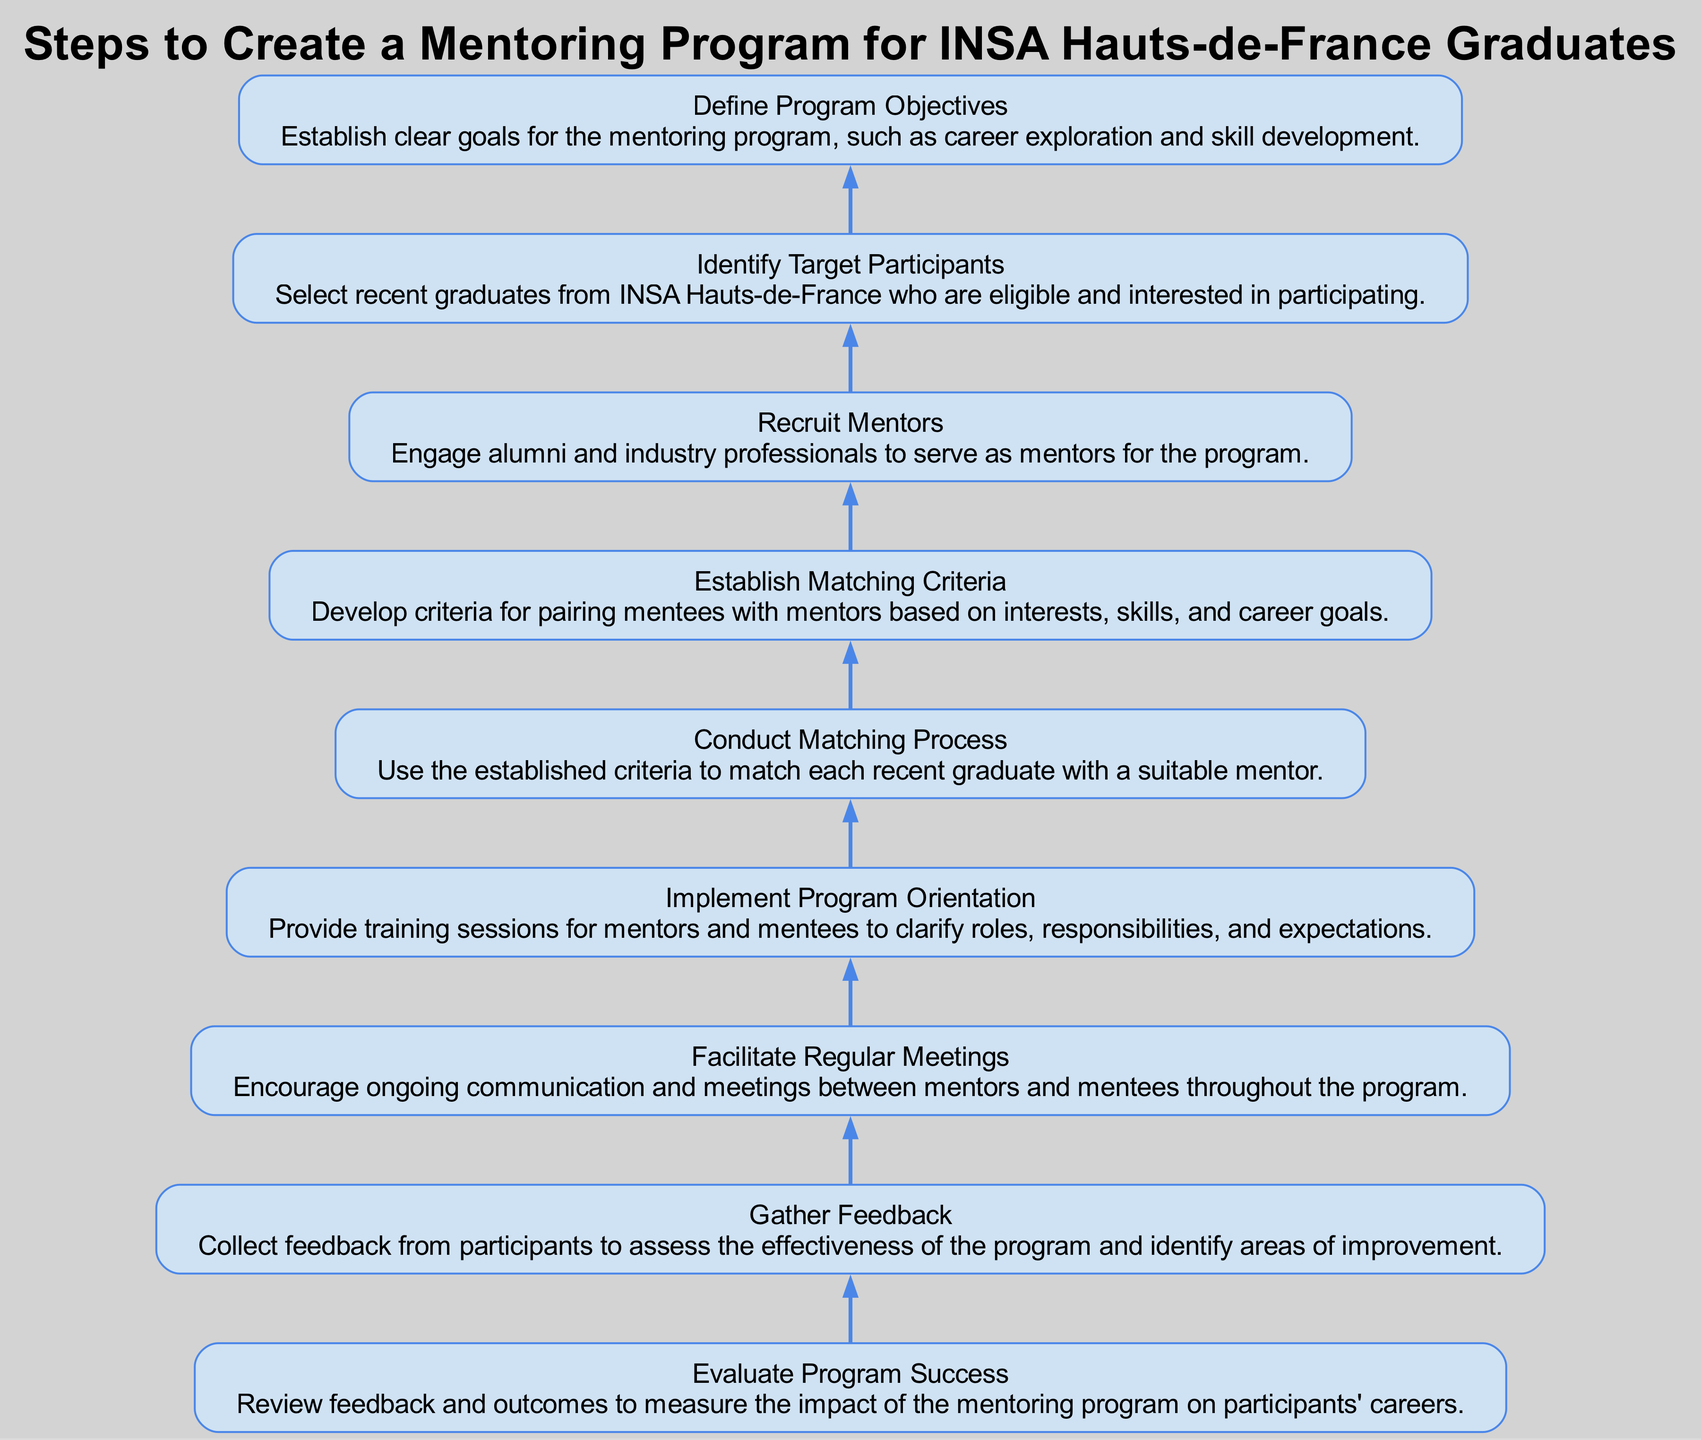What is the first step in the mentoring program? The first step is to "Define Program Objectives". This is the starting point in the flow chart, as it is at the bottom before any other process begins.
Answer: Define Program Objectives How many nodes are in the diagram? The diagram contains a total of nine nodes, which represent different steps in creating the mentoring program. Each step is a distinct node in the flow.
Answer: Nine What is the last step of the mentoring program? The last step is "Evaluate Program Success". The flow chart lists this step at the top, after all subsequent steps have been completed.
Answer: Evaluate Program Success What follows after "Recruit Mentors"? After "Recruit Mentors", the next step is "Establish Matching Criteria". This indicates the flow of processes where recruitment leads to determining how to match mentors with mentees.
Answer: Establish Matching Criteria What are the matching criteria based on? The matching criteria are based on interests, skills, and career goals. This is outlined in the description of the "Establish Matching Criteria" step in the diagram.
Answer: Interests, skills, and career goals How many steps are focused on feedback? There are two steps that focus on feedback: "Gather Feedback" and "Evaluate Program Success". This shows that participants are encouraged to provide feedback during and after the program.
Answer: Two What is the purpose of "Implement Program Orientation"? The purpose is to provide training sessions for both mentors and mentees, clarifying roles and expectations. This ensures that participants understand their responsibilities clearly.
Answer: Clarify roles and expectations Which step directly precedes the "Gather Feedback" step? The step that directly precedes "Gather Feedback" is "Facilitate Regular Meetings". This indicates that ongoing communication is important before collecting feedback.
Answer: Facilitate Regular Meetings What action is taken after collecting feedback? After collecting feedback, the action taken is to "Evaluate Program Success". This step focuses on reviewing the gathered feedback to assess the program's effectiveness.
Answer: Evaluate Program Success 